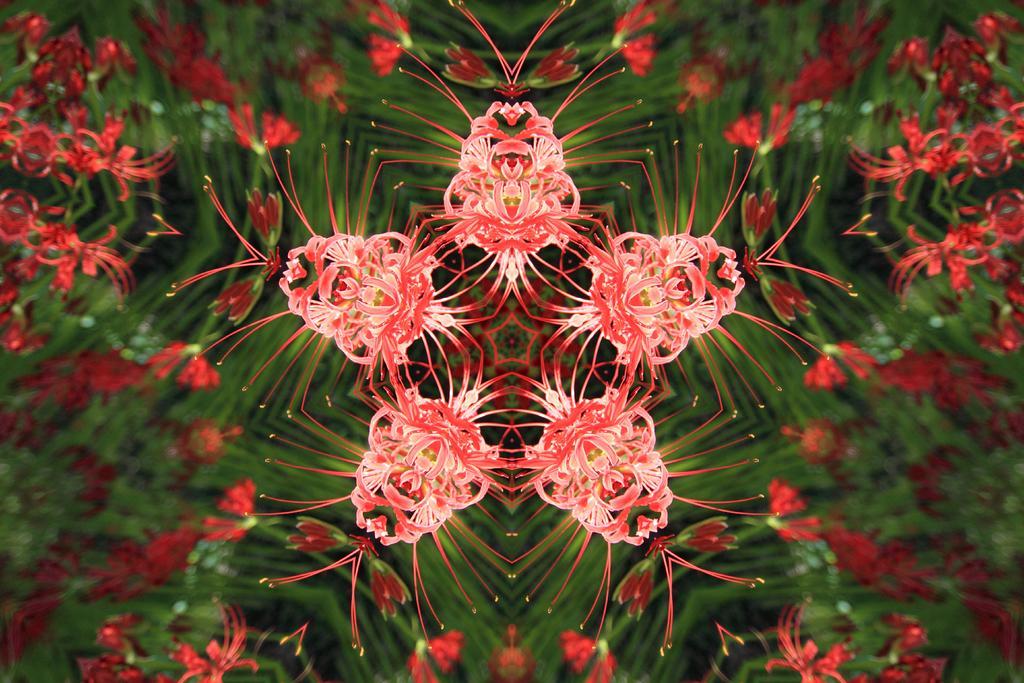In one or two sentences, can you explain what this image depicts? In the picture we can see a plant with a flower on the glass with five time images. 